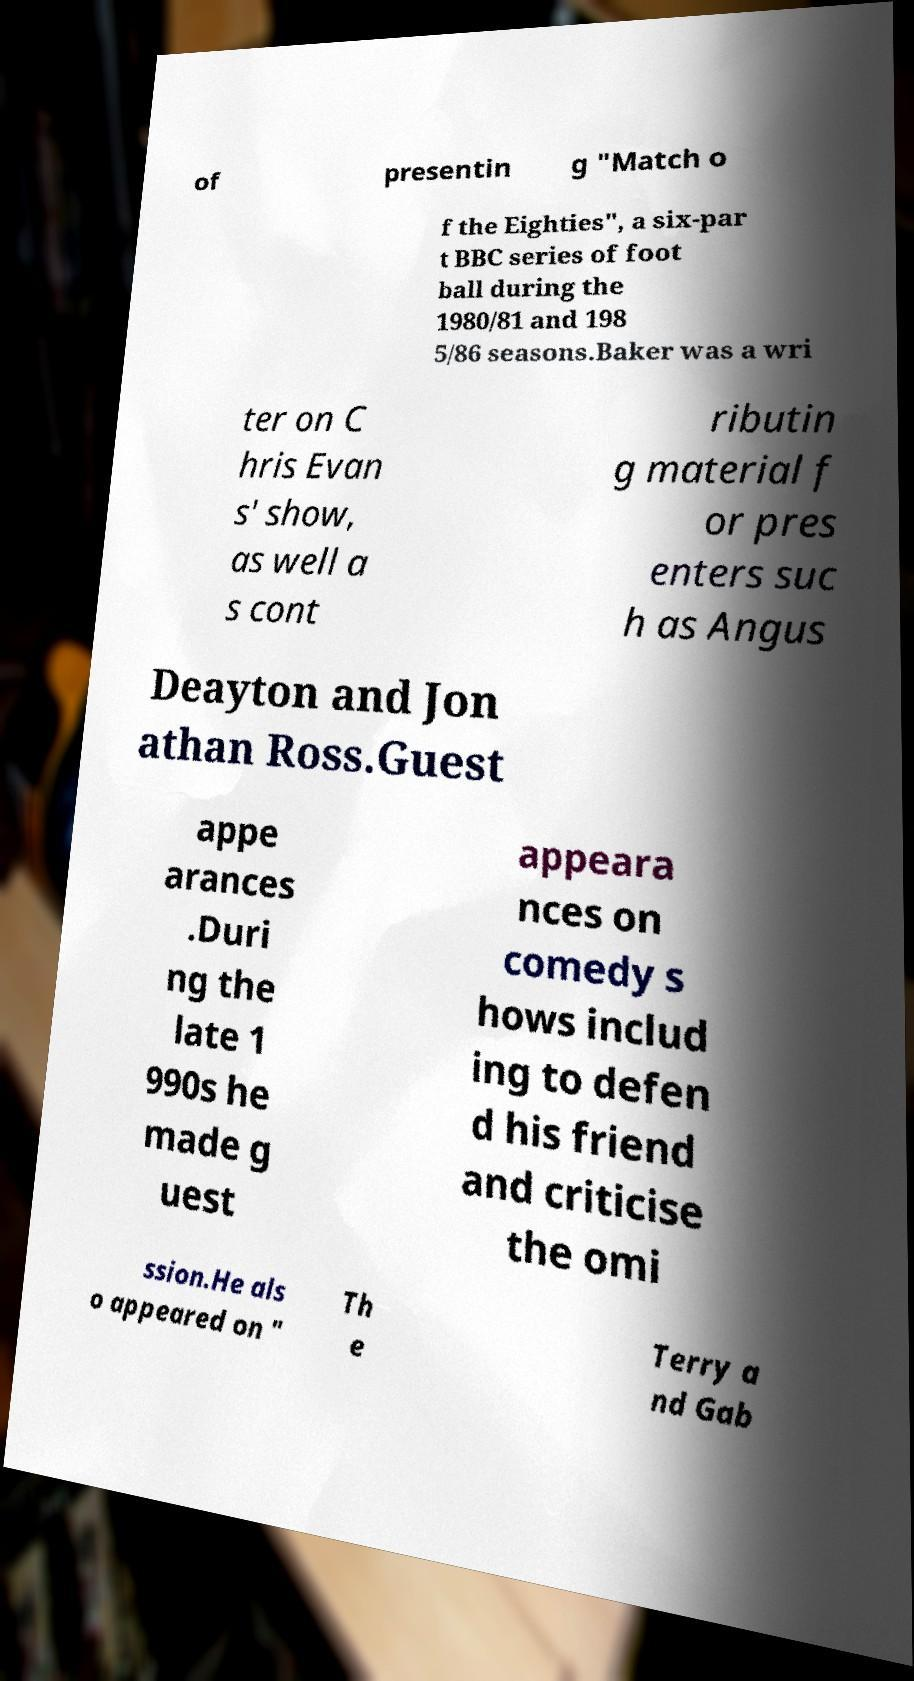Can you read and provide the text displayed in the image?This photo seems to have some interesting text. Can you extract and type it out for me? of presentin g "Match o f the Eighties", a six-par t BBC series of foot ball during the 1980/81 and 198 5/86 seasons.Baker was a wri ter on C hris Evan s' show, as well a s cont ributin g material f or pres enters suc h as Angus Deayton and Jon athan Ross.Guest appe arances .Duri ng the late 1 990s he made g uest appeara nces on comedy s hows includ ing to defen d his friend and criticise the omi ssion.He als o appeared on " Th e Terry a nd Gab 